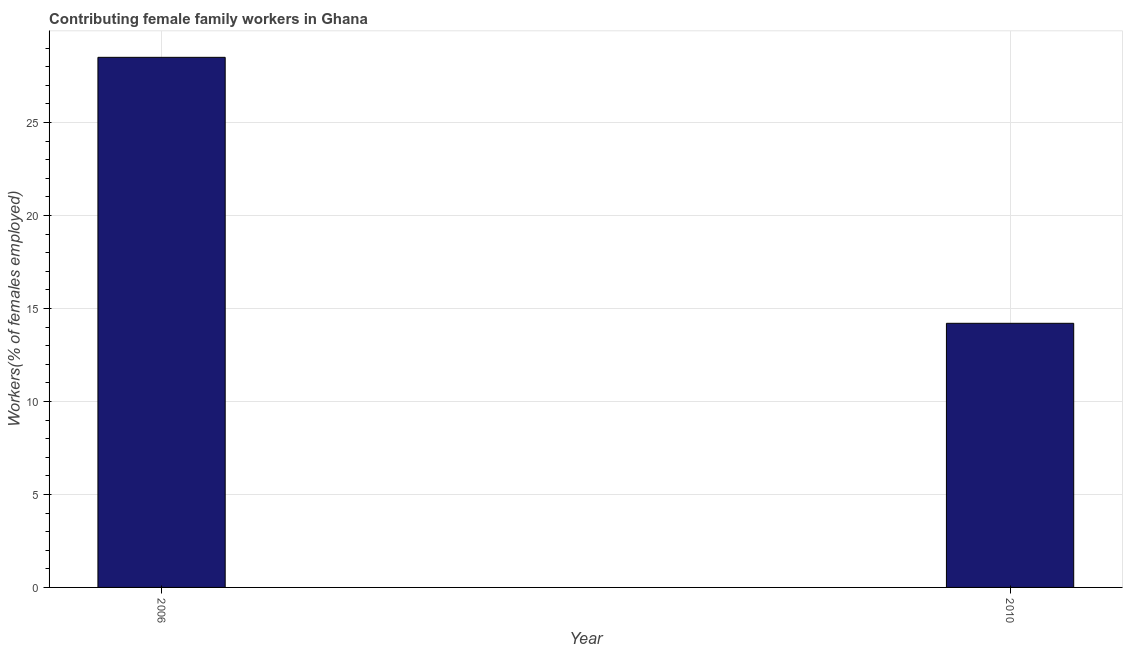What is the title of the graph?
Offer a very short reply. Contributing female family workers in Ghana. What is the label or title of the Y-axis?
Your answer should be compact. Workers(% of females employed). What is the contributing female family workers in 2010?
Make the answer very short. 14.2. Across all years, what is the minimum contributing female family workers?
Provide a succinct answer. 14.2. In which year was the contributing female family workers maximum?
Provide a succinct answer. 2006. What is the sum of the contributing female family workers?
Give a very brief answer. 42.7. What is the average contributing female family workers per year?
Offer a very short reply. 21.35. What is the median contributing female family workers?
Keep it short and to the point. 21.35. Do a majority of the years between 2006 and 2010 (inclusive) have contributing female family workers greater than 3 %?
Ensure brevity in your answer.  Yes. What is the ratio of the contributing female family workers in 2006 to that in 2010?
Offer a very short reply. 2.01. Is the contributing female family workers in 2006 less than that in 2010?
Make the answer very short. No. How many bars are there?
Your response must be concise. 2. Are all the bars in the graph horizontal?
Keep it short and to the point. No. How many years are there in the graph?
Offer a terse response. 2. Are the values on the major ticks of Y-axis written in scientific E-notation?
Ensure brevity in your answer.  No. What is the Workers(% of females employed) in 2006?
Ensure brevity in your answer.  28.5. What is the Workers(% of females employed) in 2010?
Offer a terse response. 14.2. What is the difference between the Workers(% of females employed) in 2006 and 2010?
Offer a very short reply. 14.3. What is the ratio of the Workers(% of females employed) in 2006 to that in 2010?
Offer a terse response. 2.01. 